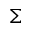Convert formula to latex. <formula><loc_0><loc_0><loc_500><loc_500>\Sigma</formula> 